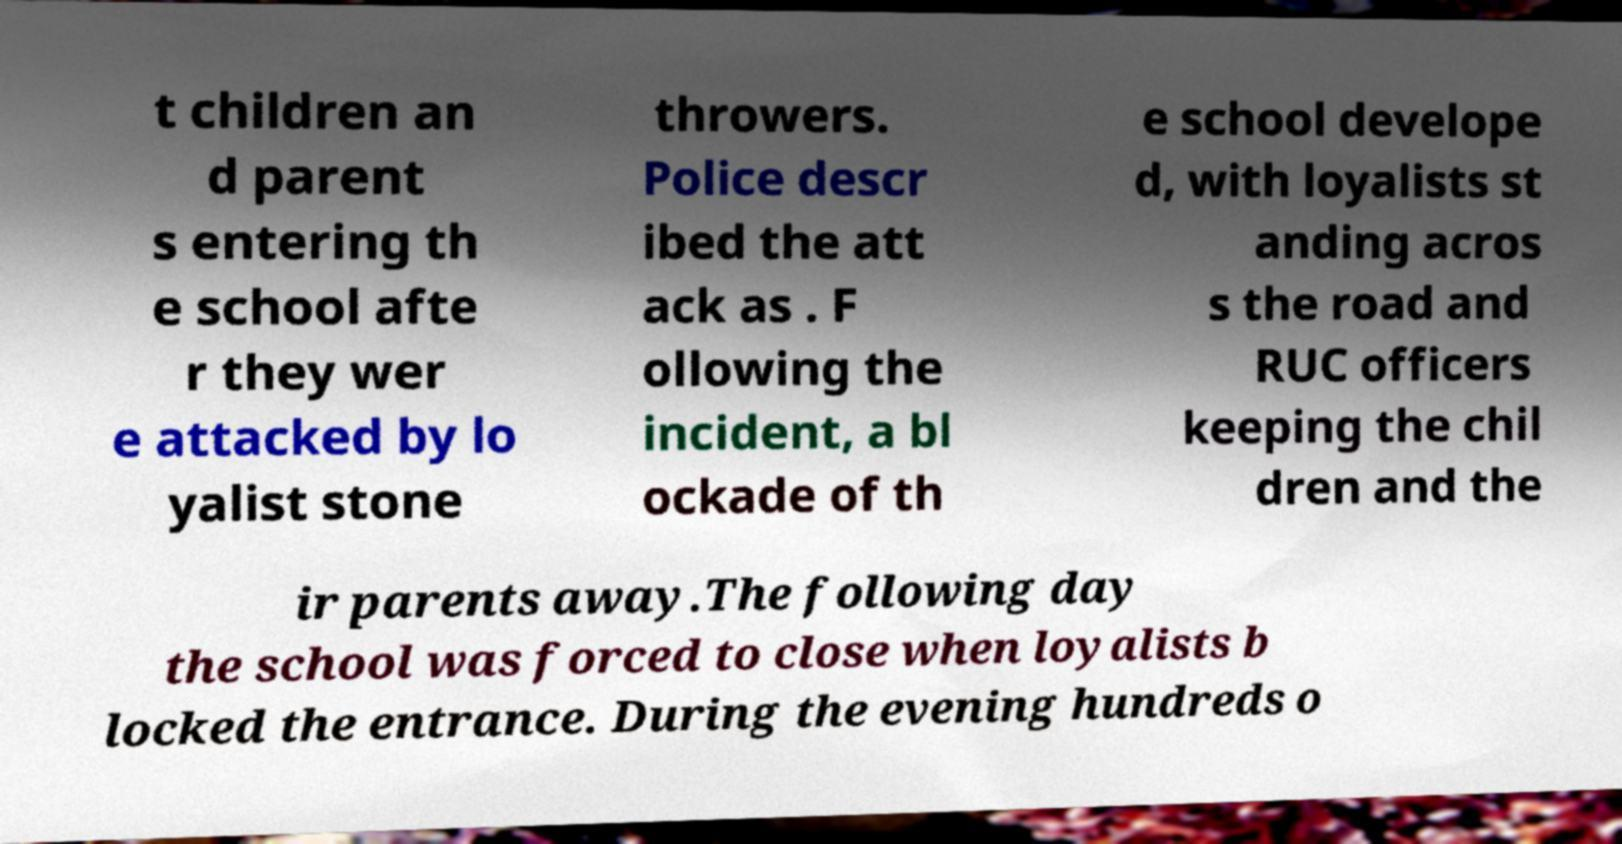Could you extract and type out the text from this image? t children an d parent s entering th e school afte r they wer e attacked by lo yalist stone throwers. Police descr ibed the att ack as . F ollowing the incident, a bl ockade of th e school develope d, with loyalists st anding acros s the road and RUC officers keeping the chil dren and the ir parents away.The following day the school was forced to close when loyalists b locked the entrance. During the evening hundreds o 